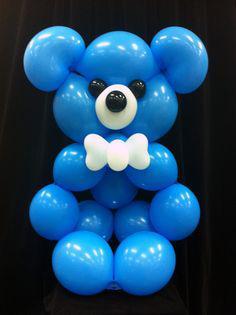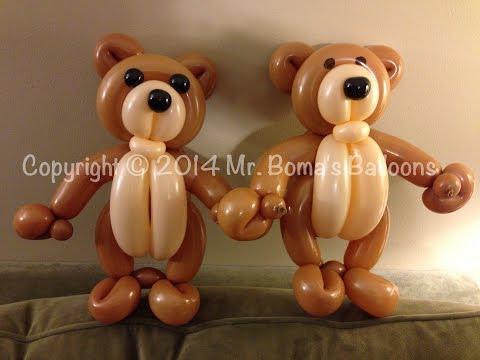The first image is the image on the left, the second image is the image on the right. For the images displayed, is the sentence "The right-hand image features a single balloon animal." factually correct? Answer yes or no. No. 